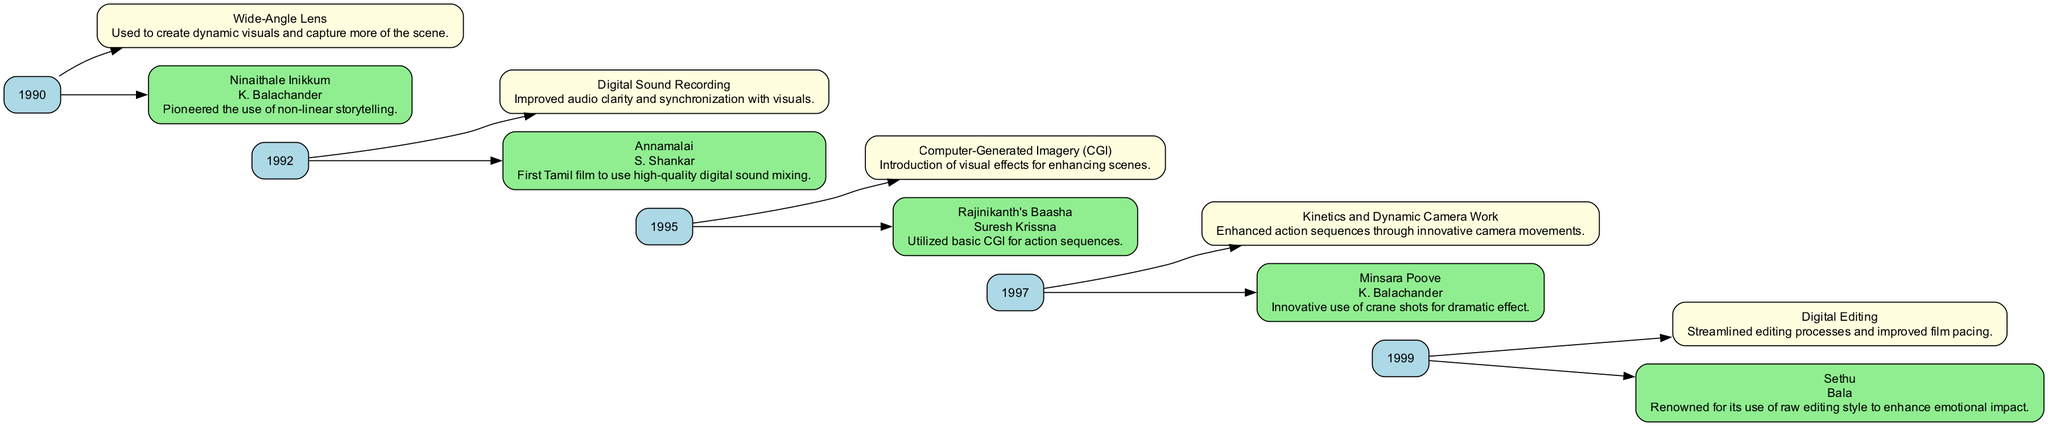What technique was introduced in 1990? The diagram shows that in 1990, the technique introduced was "Wide-Angle Lens." This is directly linked to the year node, allowing for easy identification of what was relevant during that time.
Answer: Wide-Angle Lens Which film first used high-quality digital sound mixing? According to the flow chart, the film "Annamalai," directed by S. Shankar in 1992, is noted for being the first Tamil film to use high-quality digital sound mixing, linking the film node to that specific advancement.
Answer: Annamalai How many notable filmmakers are mentioned in the diagram? The diagram outlines five advancements and links them to their respective filmmakers, totaling five filmmakers: K. Balachander, S. Shankar, Suresh Krissna, K. Balachander, and Bala. Counting these names gives a straightforward total.
Answer: 5 What technology was used in 1995 for action sequences? In the year 1995, the diagram indicates that "Computer-Generated Imagery (CGI)" was used, specifically in the film "Rajinikanth's Baasha" for enhancing action sequences, showing the connection between the year and the advancement.
Answer: Computer-Generated Imagery (CGI) Which year features the technique of digital editing? The diagram clearly marks 1999 as the year featuring the "Digital Editing" technique, which is explicitly connected to that year's advancements, showcasing the evolution of techniques toward the end of the decade.
Answer: 1999 What notable technique was used in the film "Minsara Poove"? The flow chart identifies "Kinetics and Dynamic Camera Work" as the notable technique used in "Minsara Poove," linking the film node to its respective technological advancement and emphasizing innovative camera movements.
Answer: Kinetics and Dynamic Camera Work How many advancements are listed for the year 1992? In 1992, the diagram illustrates two advancements: "Digital Sound Recording" and the application in "Annamalai," indicating that this year had a pair of notable advancements to showcase.
Answer: 2 What innovation is associated with the film "Sethu"? Based on the flow chart, "Sethu," directed by Bala in 1999, is associated with the innovation of using a raw editing style to enhance emotional impact, directly correlating the film node with its unique innovation.
Answer: Raw editing style What describes the description of the technique introduced in 1990? The technique "Wide-Angle Lens" introduced in 1990 is described as being used to create dynamic visuals and capture more of the scene, as shown in the diagram's description linked to that technique node.
Answer: Create dynamic visuals and capture more of the scene 